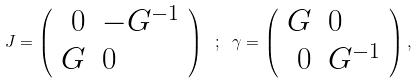<formula> <loc_0><loc_0><loc_500><loc_500>J = \left ( \begin{array} { r l } 0 & - G ^ { - 1 } \\ G & 0 \end{array} \right ) \ ; \ \gamma = \left ( \begin{array} { r l } G & 0 \\ 0 & G ^ { - 1 } \end{array} \right ) ,</formula> 